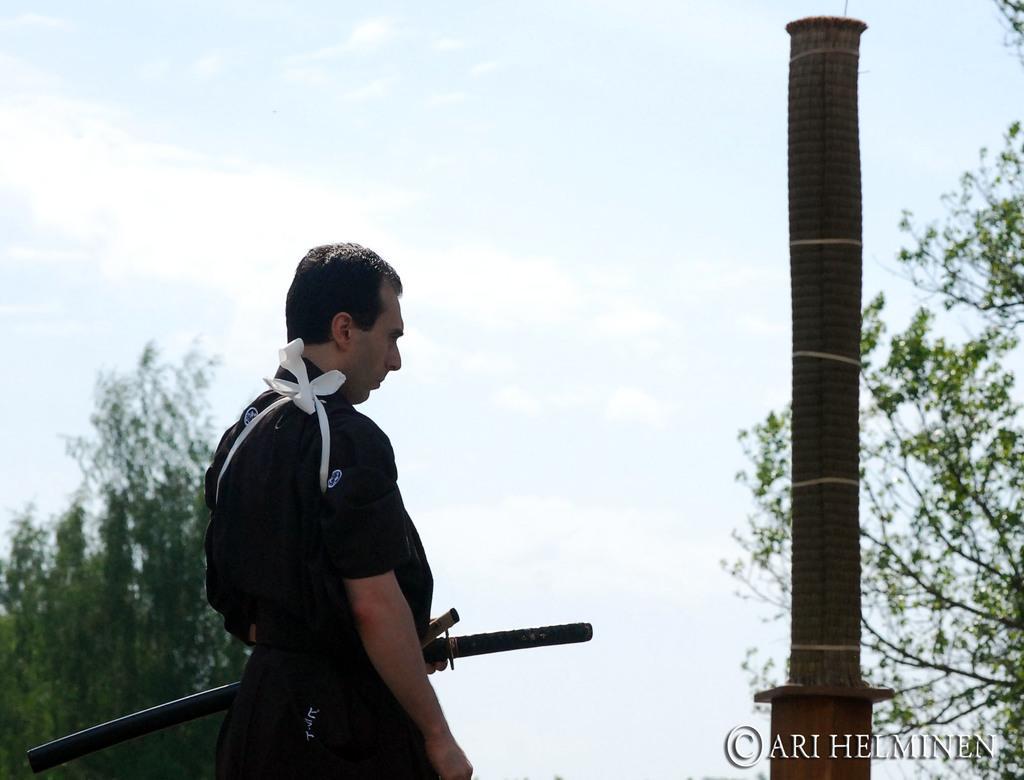Describe this image in one or two sentences. In this image we can see a man on the left side and he is holding a sword in his hand. In the background there are trees, poles and clouds in the sky. 